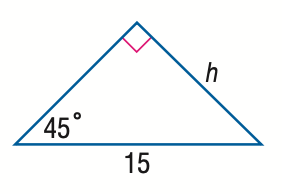Answer the mathemtical geometry problem and directly provide the correct option letter.
Question: Find h in the triangle.
Choices: A: \frac { 15 \sqrt 2 } { 3 } B: \frac { 15 } { 2 } C: \frac { 15 \sqrt 2 } { 2 } D: 15 C 